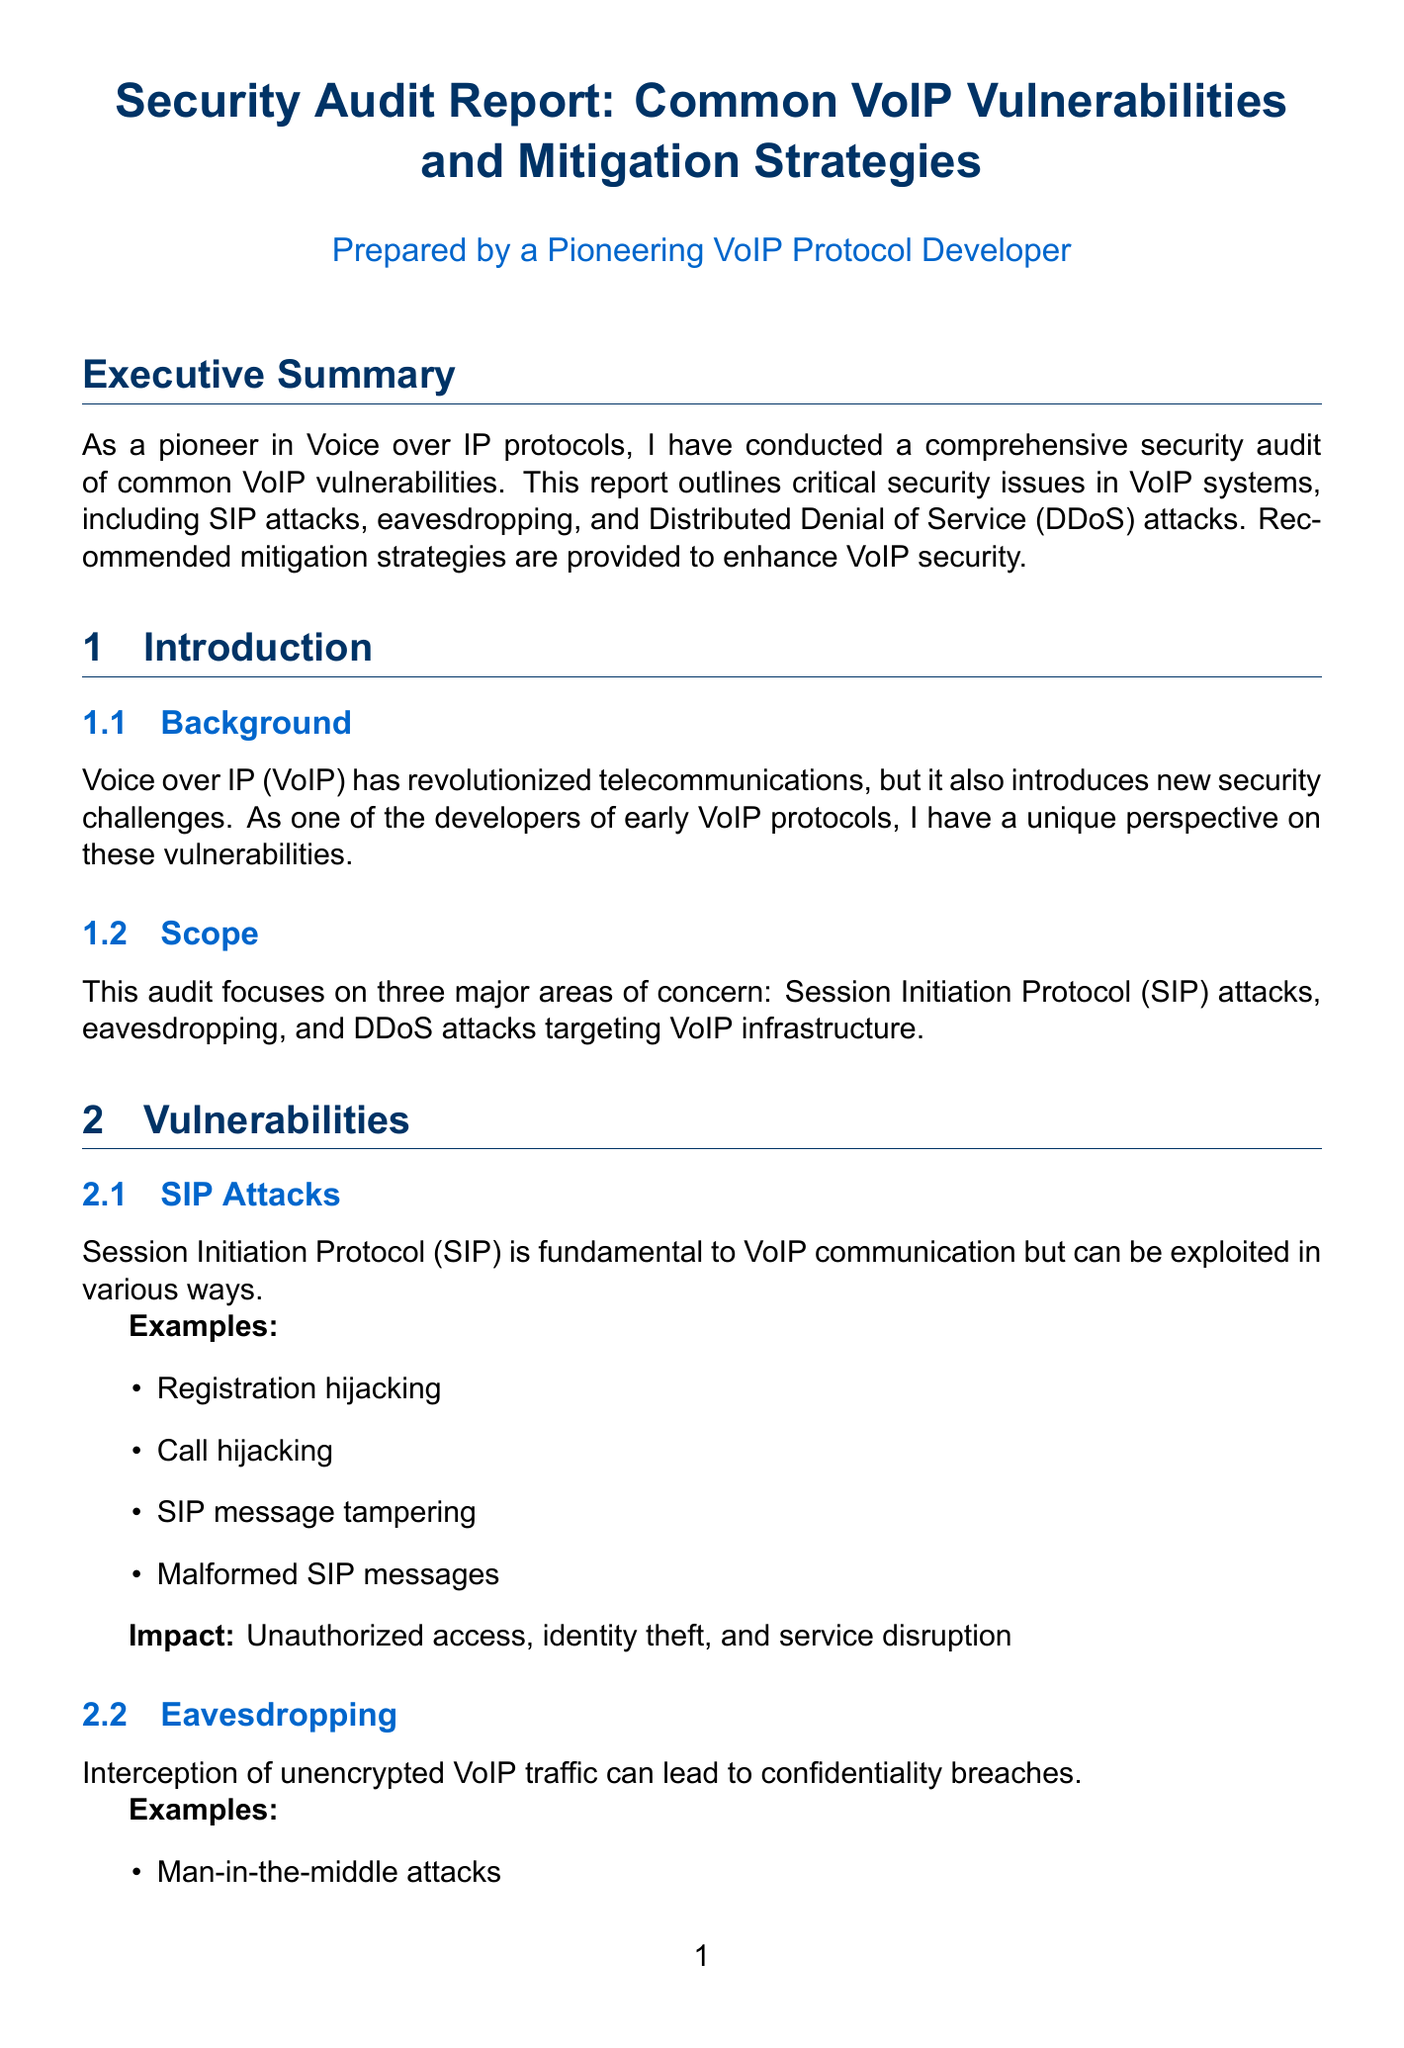What are the three major areas of concern in the audit? The audit focuses on the vulnerabilities related to SIP attacks, eavesdropping, and DDoS attacks.
Answer: SIP attacks, eavesdropping, DDoS attacks What is the impact of eavesdropping on VoIP communications? The impact includes privacy violations, data theft, and corporate espionage.
Answer: Privacy violations, data theft, corporate espionage How many specific examples of SIP attacks are provided in the report? There are four examples listed under SIP attacks in the vulnerabilities section.
Answer: Four What is one recommended strategy for mitigating DDoS attacks? The report suggests implementing rate limiting and traffic shaping as a mitigation strategy.
Answer: Rate limiting and traffic shaping Which company experienced a SIP attack that resulted in unauthorized international calls? The case study describes a large telecommunications company as the victim of the SIP attack in 2019.
Answer: Large telecommunications company What type of encryption is recommended for media in VoIP communications? The document recommends using SRTP for media encryption.
Answer: SRTP What was the outcome of the eavesdropping incident at the Fortune 500 company? The outcome was the deployment of SRTP for all VoIP communications and the implementation of a comprehensive employee training program.
Answer: Deployment of SRTP and employee training program What is the primary goal of the security audit report? The goal is to outline critical security issues in VoIP systems and provide recommended mitigation strategies.
Answer: Outline critical security issues and provide mitigation strategies 